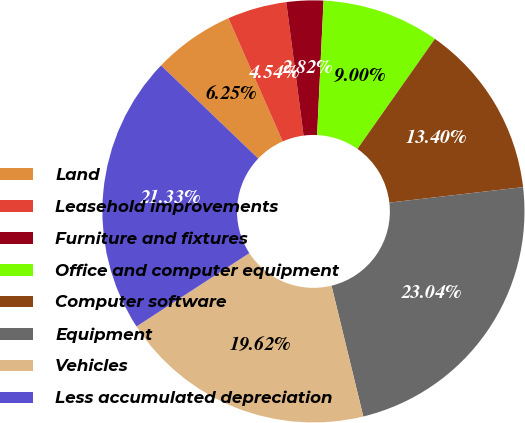Convert chart. <chart><loc_0><loc_0><loc_500><loc_500><pie_chart><fcel>Land<fcel>Leasehold improvements<fcel>Furniture and fixtures<fcel>Office and computer equipment<fcel>Computer software<fcel>Equipment<fcel>Vehicles<fcel>Less accumulated depreciation<nl><fcel>6.25%<fcel>4.54%<fcel>2.82%<fcel>9.0%<fcel>13.4%<fcel>23.04%<fcel>19.62%<fcel>21.33%<nl></chart> 